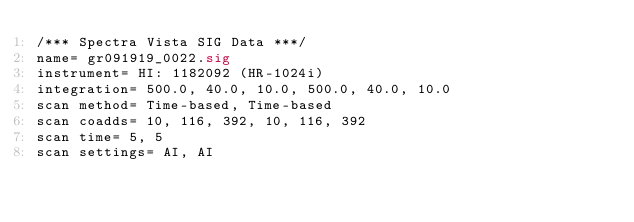Convert code to text. <code><loc_0><loc_0><loc_500><loc_500><_SML_>/*** Spectra Vista SIG Data ***/
name= gr091919_0022.sig
instrument= HI: 1182092 (HR-1024i)
integration= 500.0, 40.0, 10.0, 500.0, 40.0, 10.0
scan method= Time-based, Time-based
scan coadds= 10, 116, 392, 10, 116, 392
scan time= 5, 5
scan settings= AI, AI</code> 